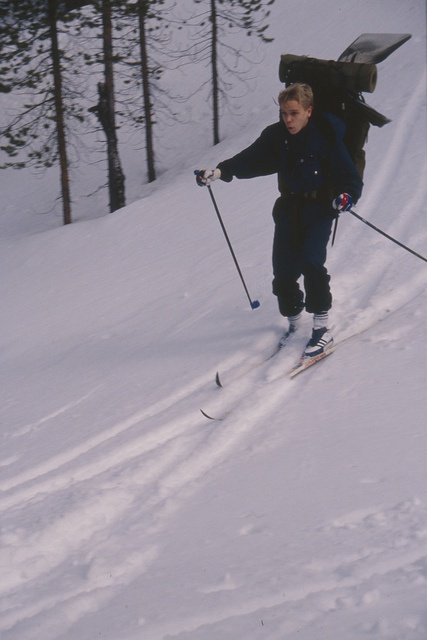Describe the objects in this image and their specific colors. I can see people in gray, black, darkgray, and maroon tones, skis in gray, darkgray, and lightgray tones, and backpack in gray and black tones in this image. 